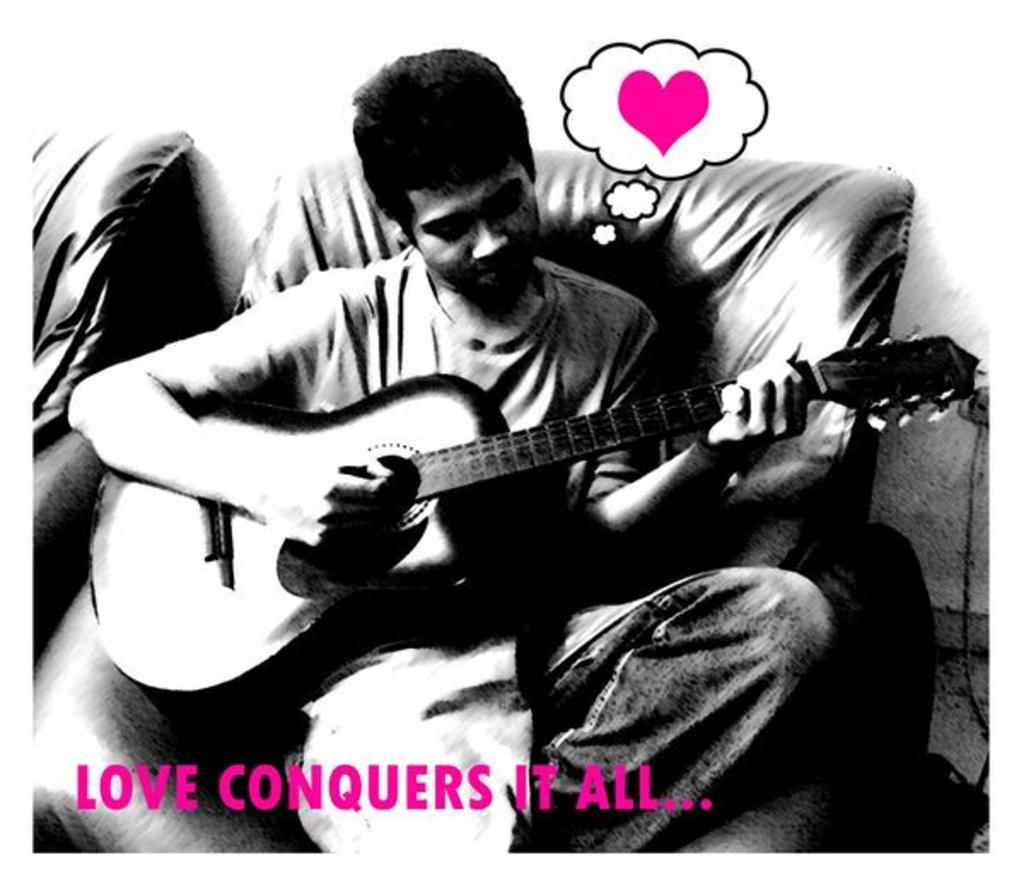What is the man in the image doing? The man is playing a guitar in the image. What object can be seen in the image that might be used for sitting? There is a sofa in the image that can be used for sitting. What is visible in the background of the image? There is a wall in the background of the image. How many friends does the man have in the image? There is no information about friends in the image; it only shows a man playing a guitar. What type of record is being played in the image? There is no record or music player visible in the image. 